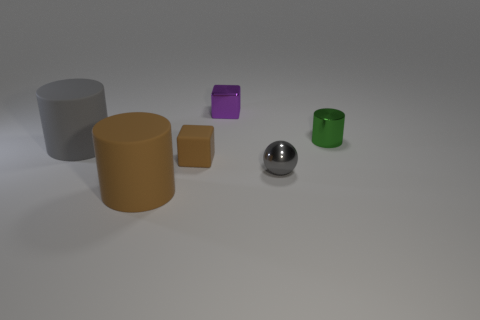What number of other rubber things are the same shape as the small green object?
Keep it short and to the point. 2. How many other things are the same material as the tiny green thing?
Provide a succinct answer. 2. There is a thing that is the same color as the tiny sphere; what is its shape?
Your response must be concise. Cylinder. There is a brown rubber cube that is in front of the shiny cylinder; how big is it?
Your answer should be compact. Small. There is a tiny purple object that is the same material as the ball; what is its shape?
Give a very brief answer. Cube. Does the purple thing have the same material as the gray cylinder left of the big brown rubber cylinder?
Offer a very short reply. No. Does the large object in front of the tiny gray shiny thing have the same shape as the green metallic object?
Your response must be concise. Yes. There is another small object that is the same shape as the tiny brown rubber object; what is it made of?
Give a very brief answer. Metal. There is a small green metallic object; is it the same shape as the gray thing to the right of the small brown matte block?
Keep it short and to the point. No. There is a cylinder that is both in front of the small green shiny cylinder and behind the brown cube; what is its color?
Ensure brevity in your answer.  Gray. 